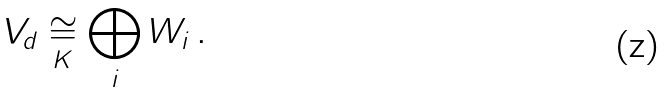Convert formula to latex. <formula><loc_0><loc_0><loc_500><loc_500>V _ { d } \underset { K } \cong \bigoplus _ { i } W _ { i } \, .</formula> 